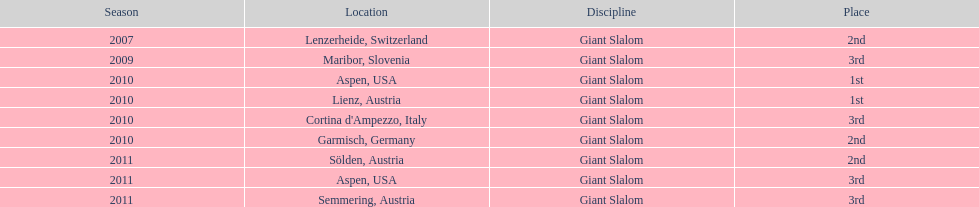What is the only location in the us? Aspen. 